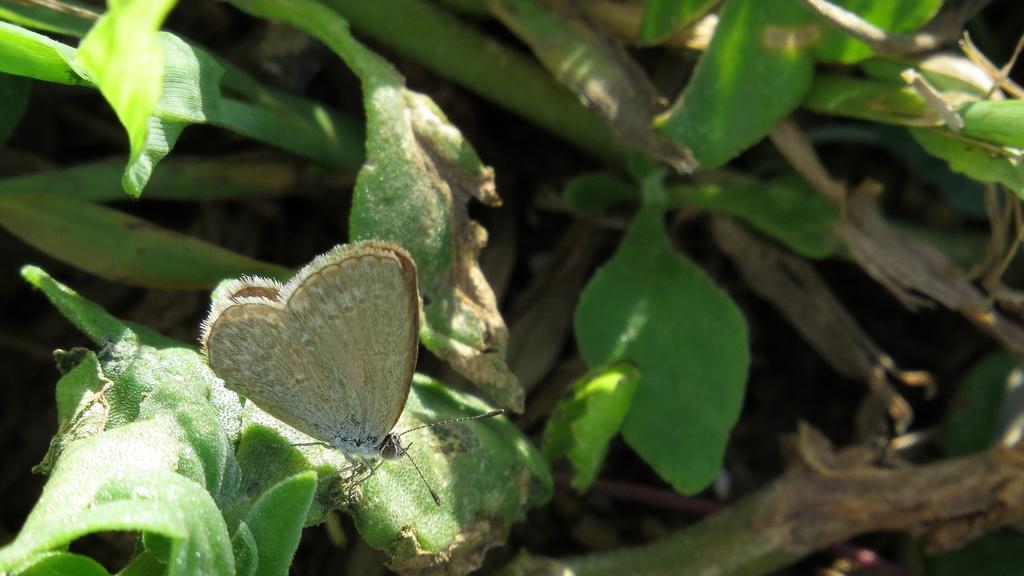How would you summarize this image in a sentence or two? In this picture I see a butterfly in front and I see number of leaves. 